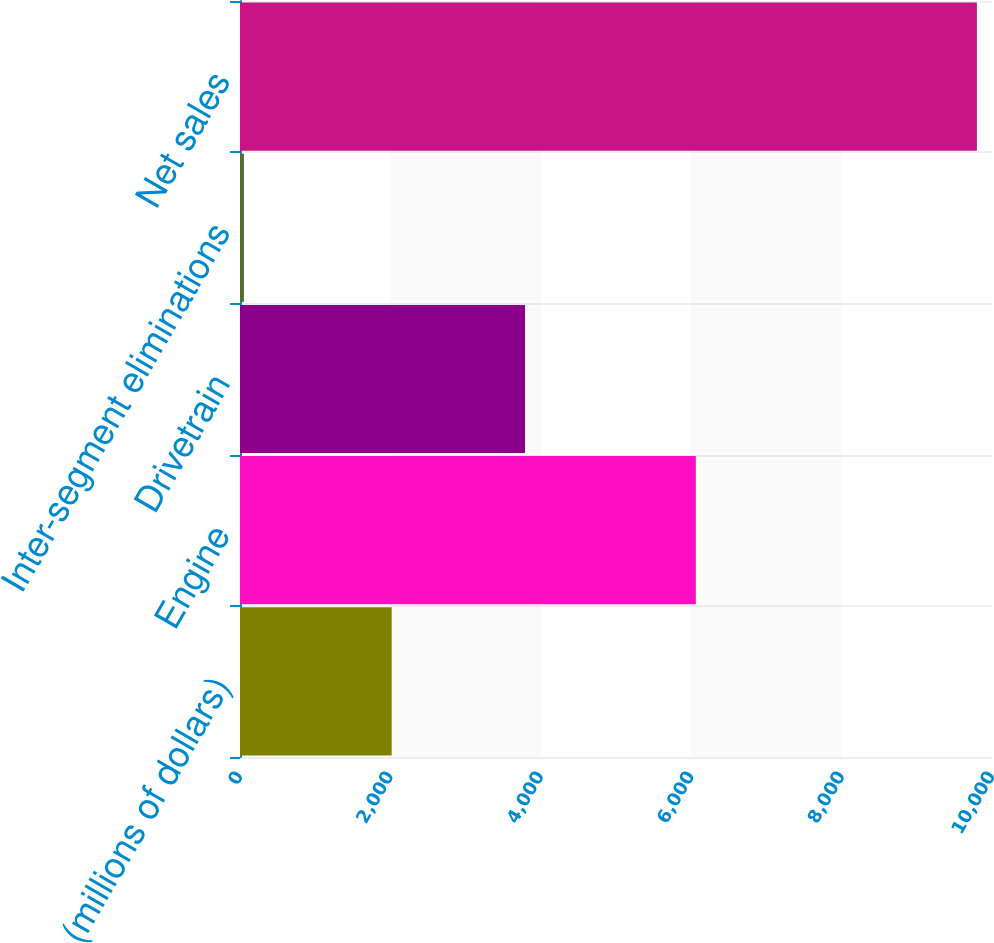<chart> <loc_0><loc_0><loc_500><loc_500><bar_chart><fcel>(millions of dollars)<fcel>Engine<fcel>Drivetrain<fcel>Inter-segment eliminations<fcel>Net sales<nl><fcel>2017<fcel>6061.5<fcel>3790.3<fcel>52.5<fcel>9799.3<nl></chart> 